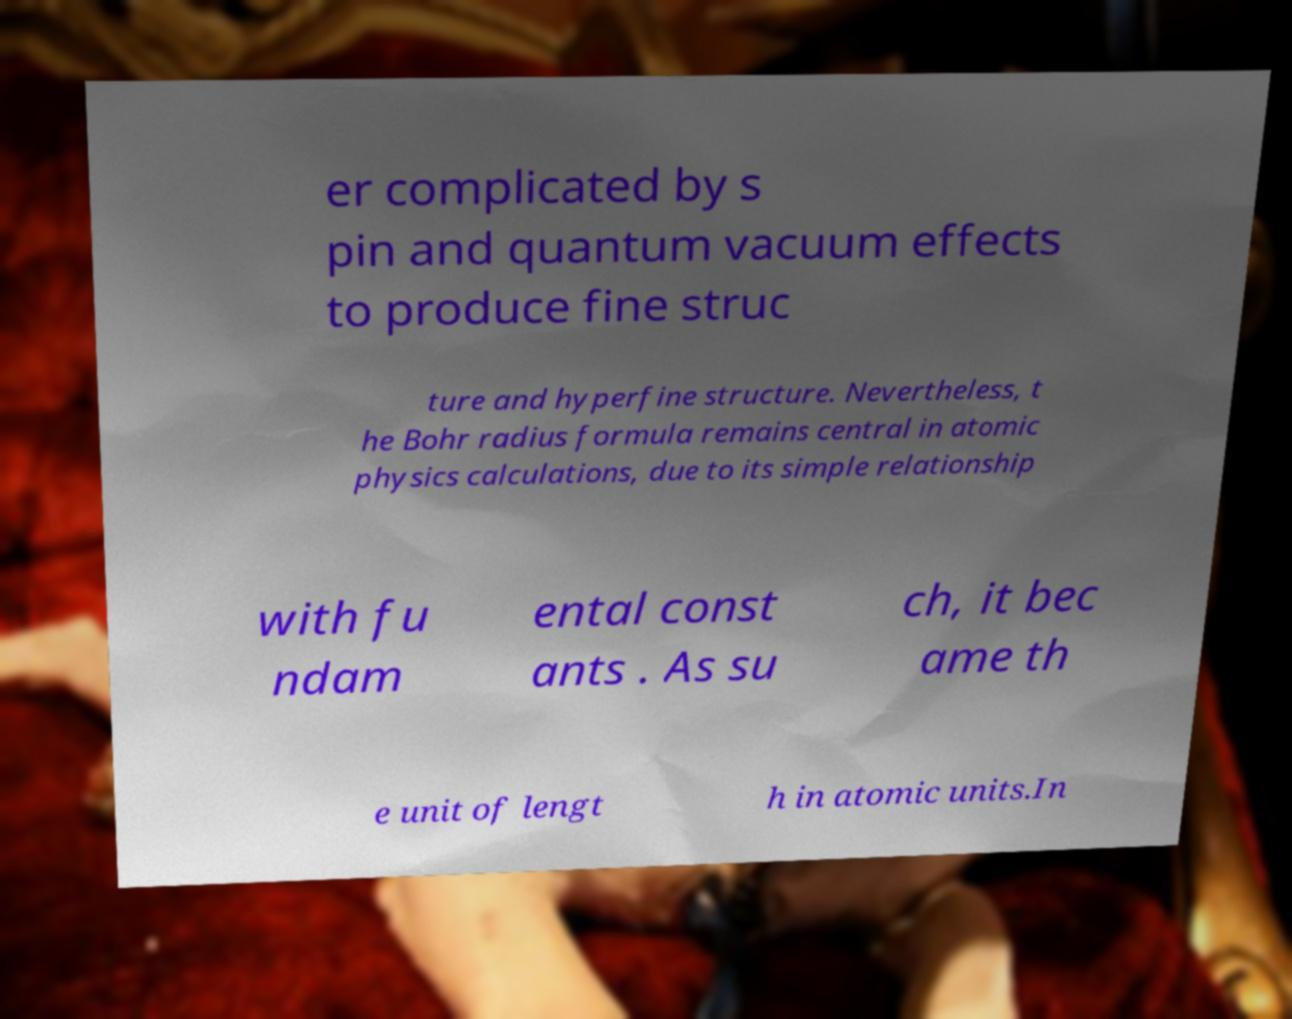For documentation purposes, I need the text within this image transcribed. Could you provide that? er complicated by s pin and quantum vacuum effects to produce fine struc ture and hyperfine structure. Nevertheless, t he Bohr radius formula remains central in atomic physics calculations, due to its simple relationship with fu ndam ental const ants . As su ch, it bec ame th e unit of lengt h in atomic units.In 